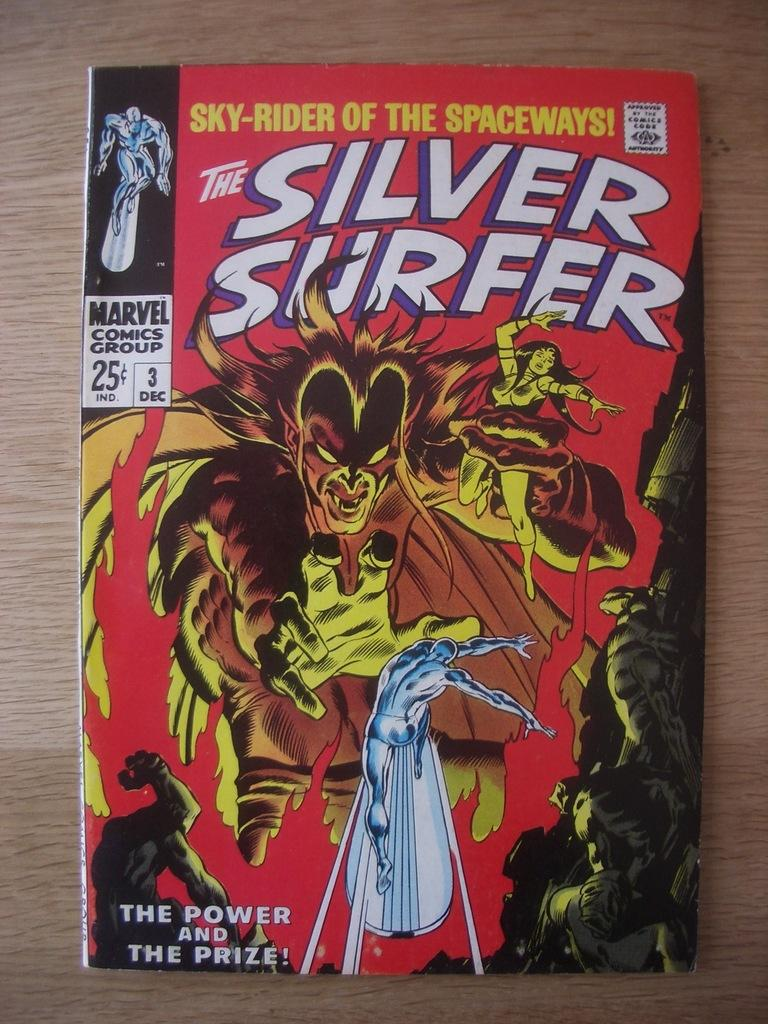Provide a one-sentence caption for the provided image. A comic book with the title The Silver Surfer with a creature holding a woman in the air on the cover. 